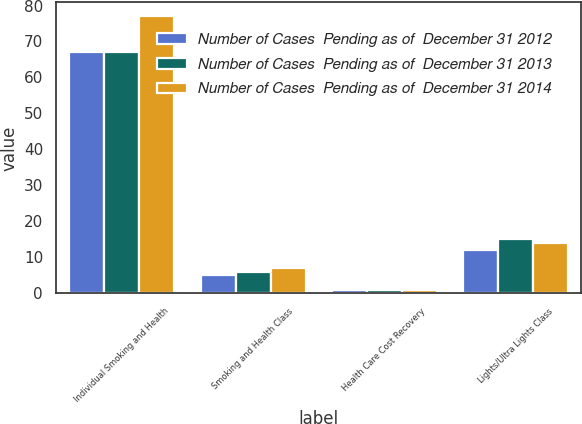<chart> <loc_0><loc_0><loc_500><loc_500><stacked_bar_chart><ecel><fcel>Individual Smoking and Health<fcel>Smoking and Health Class<fcel>Health Care Cost Recovery<fcel>Lights/Ultra Lights Class<nl><fcel>Number of Cases  Pending as of  December 31 2012<fcel>67<fcel>5<fcel>1<fcel>12<nl><fcel>Number of Cases  Pending as of  December 31 2013<fcel>67<fcel>6<fcel>1<fcel>15<nl><fcel>Number of Cases  Pending as of  December 31 2014<fcel>77<fcel>7<fcel>1<fcel>14<nl></chart> 